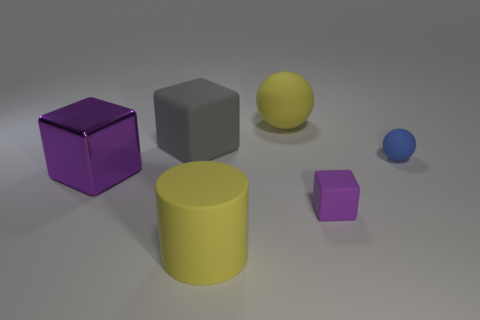How many other things are the same material as the tiny ball?
Provide a short and direct response. 4. How many rubber things are either large yellow cylinders or brown cylinders?
Offer a terse response. 1. Is the number of yellow matte cylinders less than the number of yellow rubber objects?
Ensure brevity in your answer.  Yes. There is a gray matte object; is it the same size as the block in front of the large purple block?
Make the answer very short. No. What size is the blue thing?
Give a very brief answer. Small. Are there fewer large rubber balls to the left of the big yellow sphere than tiny blue rubber cylinders?
Ensure brevity in your answer.  No. Do the purple metallic object and the purple rubber thing have the same size?
Provide a succinct answer. No. What is the color of the big ball that is made of the same material as the blue object?
Offer a very short reply. Yellow. Are there fewer tiny spheres in front of the small matte sphere than yellow things behind the metal thing?
Give a very brief answer. Yes. How many tiny rubber objects have the same color as the big metallic thing?
Keep it short and to the point. 1. 